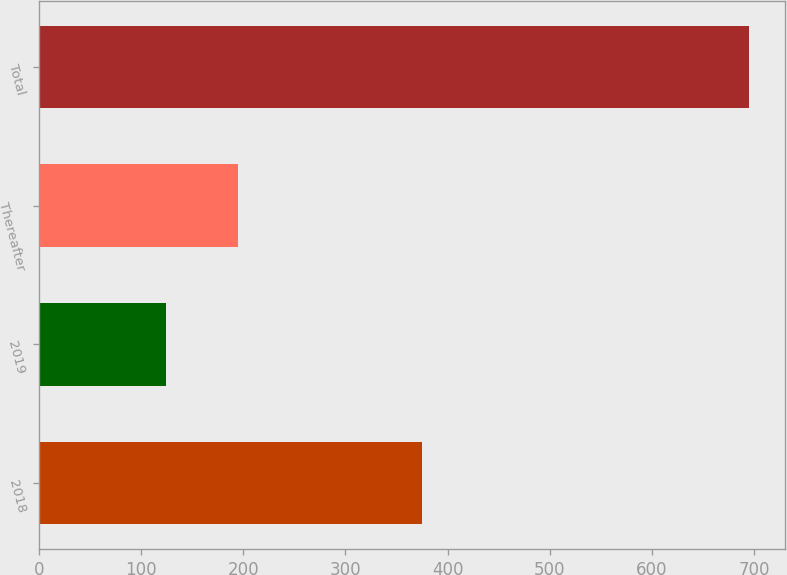Convert chart to OTSL. <chart><loc_0><loc_0><loc_500><loc_500><bar_chart><fcel>2018<fcel>2019<fcel>Thereafter<fcel>Total<nl><fcel>375<fcel>125<fcel>195<fcel>695<nl></chart> 